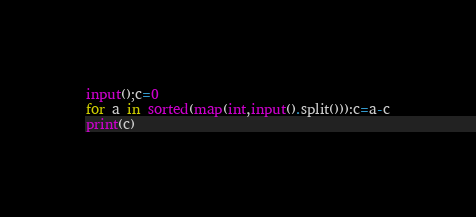<code> <loc_0><loc_0><loc_500><loc_500><_Python_>
input();c=0
for a in sorted(map(int,input().split())):c=a-c
print(c)</code> 